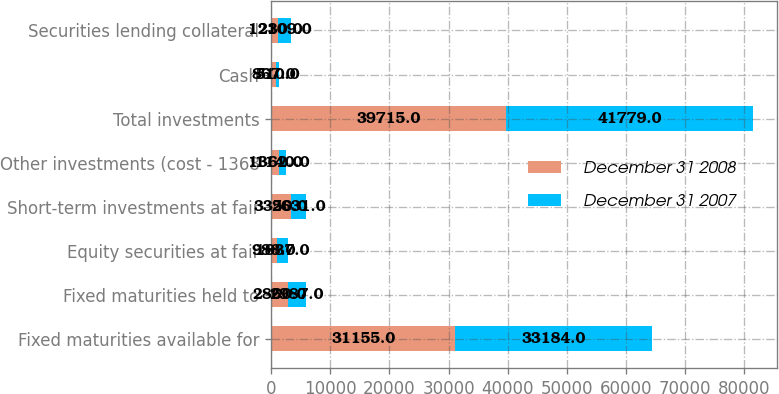Convert chart. <chart><loc_0><loc_0><loc_500><loc_500><stacked_bar_chart><ecel><fcel>Fixed maturities available for<fcel>Fixed maturities held to<fcel>Equity securities at fair<fcel>Short-term investments at fair<fcel>Other investments (cost - 1368<fcel>Total investments<fcel>Cash<fcel>Securities lending collateral<nl><fcel>December 31 2008<fcel>31155<fcel>2860<fcel>988<fcel>3350<fcel>1362<fcel>39715<fcel>867<fcel>1230<nl><fcel>December 31 2007<fcel>33184<fcel>2987<fcel>1837<fcel>2631<fcel>1140<fcel>41779<fcel>510<fcel>2109<nl></chart> 